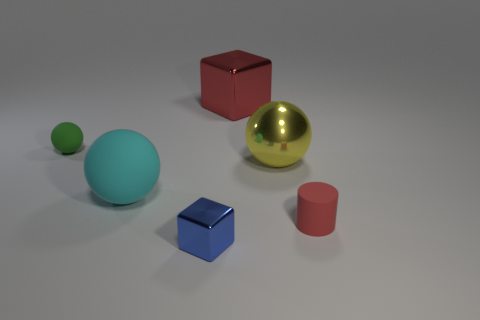How many things are both behind the tiny red cylinder and left of the large yellow shiny sphere?
Make the answer very short. 3. The green object that is the same shape as the large yellow object is what size?
Offer a terse response. Small. What number of blue blocks have the same material as the cyan thing?
Make the answer very short. 0. Is the number of tiny red cylinders that are to the left of the tiny ball less than the number of large metal objects?
Give a very brief answer. Yes. How many small metallic blocks are there?
Your answer should be compact. 1. What number of small objects are the same color as the tiny rubber sphere?
Provide a short and direct response. 0. Does the small shiny thing have the same shape as the tiny red thing?
Offer a terse response. No. How big is the block on the right side of the metallic block that is in front of the big metal cube?
Offer a very short reply. Large. Are there any objects of the same size as the red cylinder?
Your answer should be very brief. Yes. There is a block behind the large yellow thing; does it have the same size as the cylinder in front of the small green rubber ball?
Offer a terse response. No. 